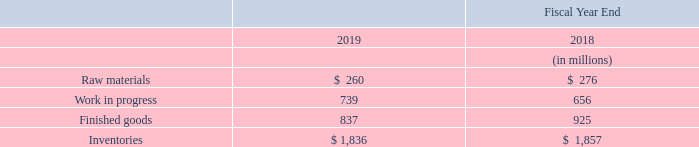6. Inventories
Inventories consisted of the following:
What was the amount of Inventories in 2019?
Answer scale should be: million. $ 1,836. In which years was the amount of Inventories calculated for? 2019, 2018. What were the components considered when calculating Inventories? Raw materials, work in progress, finished goods. In which year was Raw materials larger? 276>260
Answer: 2018. What was the change in Work in progress in 2019 from 2018?
Answer scale should be: million. 739-656
Answer: 83. What was the percentage change in Work in progress in 2019 from 2018?
Answer scale should be: percent. (739-656)/656
Answer: 12.65. 